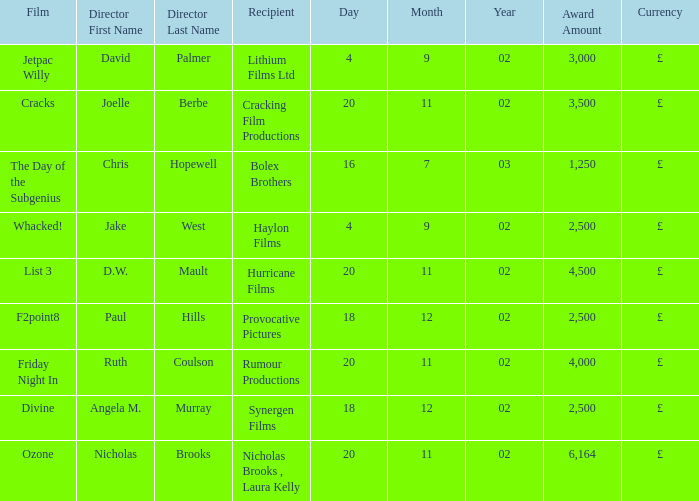Who directed a film for Cracking Film Productions? Joelle Berbe. 